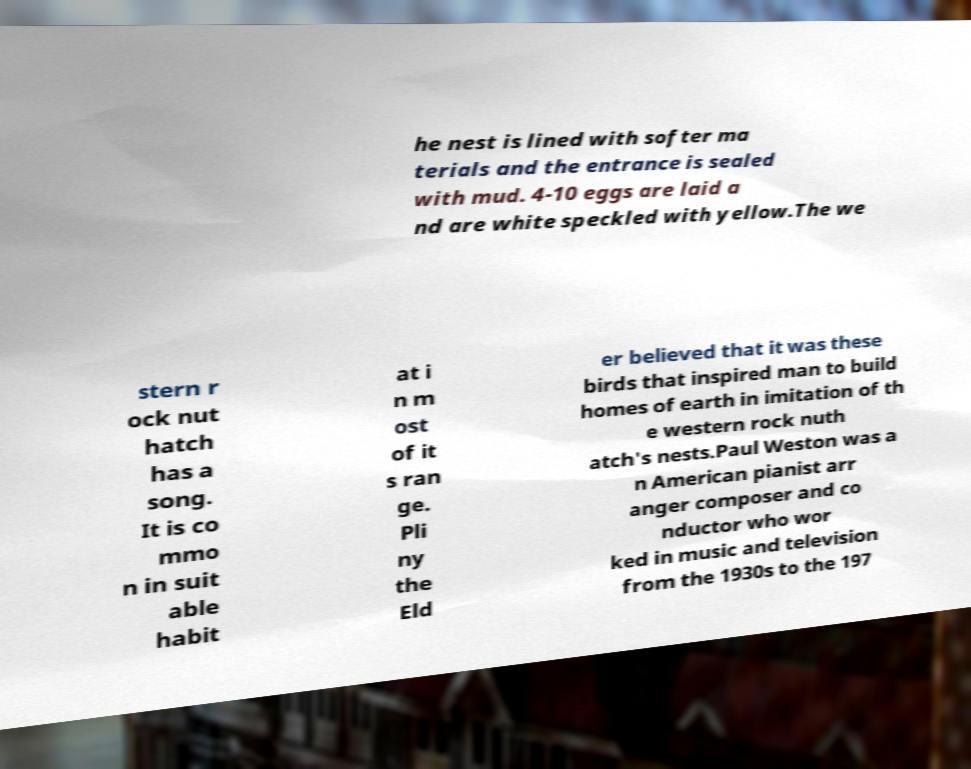Can you read and provide the text displayed in the image?This photo seems to have some interesting text. Can you extract and type it out for me? he nest is lined with softer ma terials and the entrance is sealed with mud. 4-10 eggs are laid a nd are white speckled with yellow.The we stern r ock nut hatch has a song. It is co mmo n in suit able habit at i n m ost of it s ran ge. Pli ny the Eld er believed that it was these birds that inspired man to build homes of earth in imitation of th e western rock nuth atch's nests.Paul Weston was a n American pianist arr anger composer and co nductor who wor ked in music and television from the 1930s to the 197 